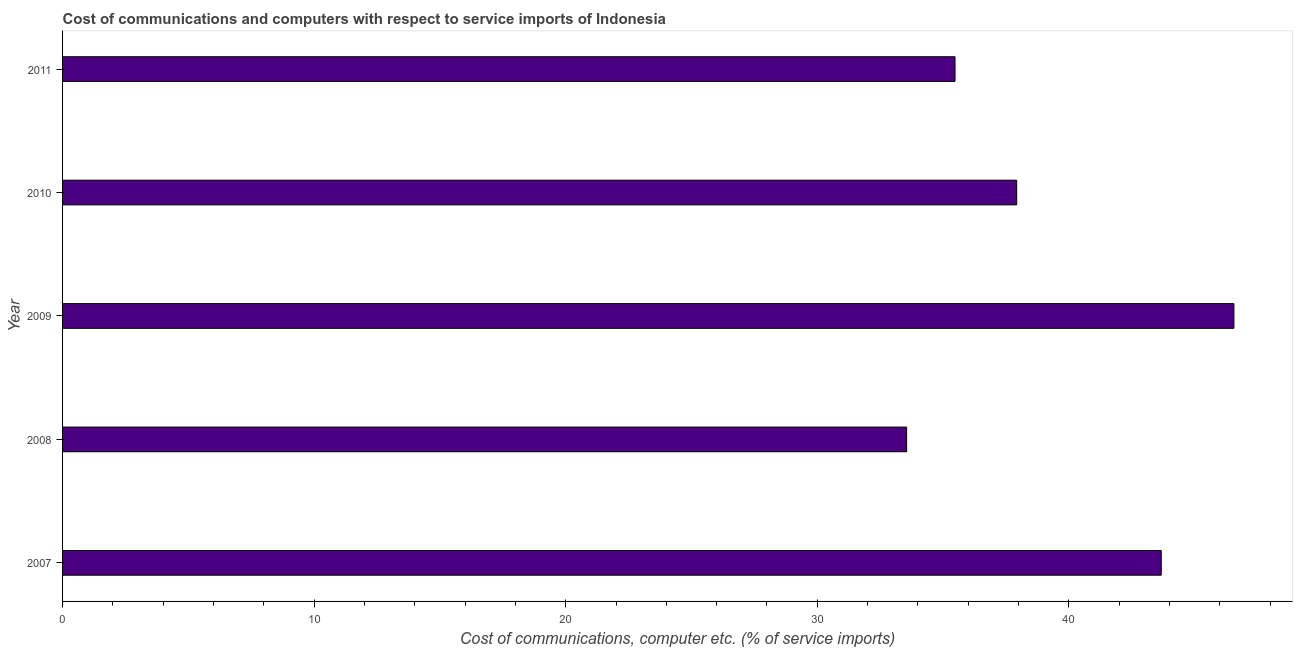Does the graph contain any zero values?
Your answer should be compact. No. What is the title of the graph?
Your answer should be very brief. Cost of communications and computers with respect to service imports of Indonesia. What is the label or title of the X-axis?
Keep it short and to the point. Cost of communications, computer etc. (% of service imports). What is the cost of communications and computer in 2011?
Give a very brief answer. 35.48. Across all years, what is the maximum cost of communications and computer?
Your response must be concise. 46.56. Across all years, what is the minimum cost of communications and computer?
Provide a succinct answer. 33.55. In which year was the cost of communications and computer maximum?
Provide a succinct answer. 2009. In which year was the cost of communications and computer minimum?
Offer a terse response. 2008. What is the sum of the cost of communications and computer?
Make the answer very short. 197.18. What is the difference between the cost of communications and computer in 2008 and 2009?
Offer a very short reply. -13.01. What is the average cost of communications and computer per year?
Your answer should be compact. 39.44. What is the median cost of communications and computer?
Ensure brevity in your answer.  37.93. In how many years, is the cost of communications and computer greater than 2 %?
Your answer should be very brief. 5. Do a majority of the years between 2008 and 2011 (inclusive) have cost of communications and computer greater than 44 %?
Provide a short and direct response. No. What is the ratio of the cost of communications and computer in 2009 to that in 2010?
Your response must be concise. 1.23. Is the cost of communications and computer in 2009 less than that in 2010?
Make the answer very short. No. What is the difference between the highest and the second highest cost of communications and computer?
Make the answer very short. 2.89. Is the sum of the cost of communications and computer in 2007 and 2010 greater than the maximum cost of communications and computer across all years?
Give a very brief answer. Yes. What is the difference between the highest and the lowest cost of communications and computer?
Your answer should be very brief. 13.01. Are all the bars in the graph horizontal?
Offer a terse response. Yes. Are the values on the major ticks of X-axis written in scientific E-notation?
Your response must be concise. No. What is the Cost of communications, computer etc. (% of service imports) in 2007?
Provide a succinct answer. 43.67. What is the Cost of communications, computer etc. (% of service imports) in 2008?
Ensure brevity in your answer.  33.55. What is the Cost of communications, computer etc. (% of service imports) of 2009?
Make the answer very short. 46.56. What is the Cost of communications, computer etc. (% of service imports) of 2010?
Ensure brevity in your answer.  37.93. What is the Cost of communications, computer etc. (% of service imports) in 2011?
Keep it short and to the point. 35.48. What is the difference between the Cost of communications, computer etc. (% of service imports) in 2007 and 2008?
Provide a short and direct response. 10.12. What is the difference between the Cost of communications, computer etc. (% of service imports) in 2007 and 2009?
Provide a succinct answer. -2.89. What is the difference between the Cost of communications, computer etc. (% of service imports) in 2007 and 2010?
Make the answer very short. 5.75. What is the difference between the Cost of communications, computer etc. (% of service imports) in 2007 and 2011?
Make the answer very short. 8.2. What is the difference between the Cost of communications, computer etc. (% of service imports) in 2008 and 2009?
Make the answer very short. -13.01. What is the difference between the Cost of communications, computer etc. (% of service imports) in 2008 and 2010?
Ensure brevity in your answer.  -4.38. What is the difference between the Cost of communications, computer etc. (% of service imports) in 2008 and 2011?
Offer a very short reply. -1.92. What is the difference between the Cost of communications, computer etc. (% of service imports) in 2009 and 2010?
Offer a terse response. 8.63. What is the difference between the Cost of communications, computer etc. (% of service imports) in 2009 and 2011?
Make the answer very short. 11.09. What is the difference between the Cost of communications, computer etc. (% of service imports) in 2010 and 2011?
Your answer should be compact. 2.45. What is the ratio of the Cost of communications, computer etc. (% of service imports) in 2007 to that in 2008?
Offer a very short reply. 1.3. What is the ratio of the Cost of communications, computer etc. (% of service imports) in 2007 to that in 2009?
Offer a very short reply. 0.94. What is the ratio of the Cost of communications, computer etc. (% of service imports) in 2007 to that in 2010?
Keep it short and to the point. 1.15. What is the ratio of the Cost of communications, computer etc. (% of service imports) in 2007 to that in 2011?
Give a very brief answer. 1.23. What is the ratio of the Cost of communications, computer etc. (% of service imports) in 2008 to that in 2009?
Keep it short and to the point. 0.72. What is the ratio of the Cost of communications, computer etc. (% of service imports) in 2008 to that in 2010?
Offer a very short reply. 0.89. What is the ratio of the Cost of communications, computer etc. (% of service imports) in 2008 to that in 2011?
Make the answer very short. 0.95. What is the ratio of the Cost of communications, computer etc. (% of service imports) in 2009 to that in 2010?
Your response must be concise. 1.23. What is the ratio of the Cost of communications, computer etc. (% of service imports) in 2009 to that in 2011?
Provide a short and direct response. 1.31. What is the ratio of the Cost of communications, computer etc. (% of service imports) in 2010 to that in 2011?
Your answer should be compact. 1.07. 